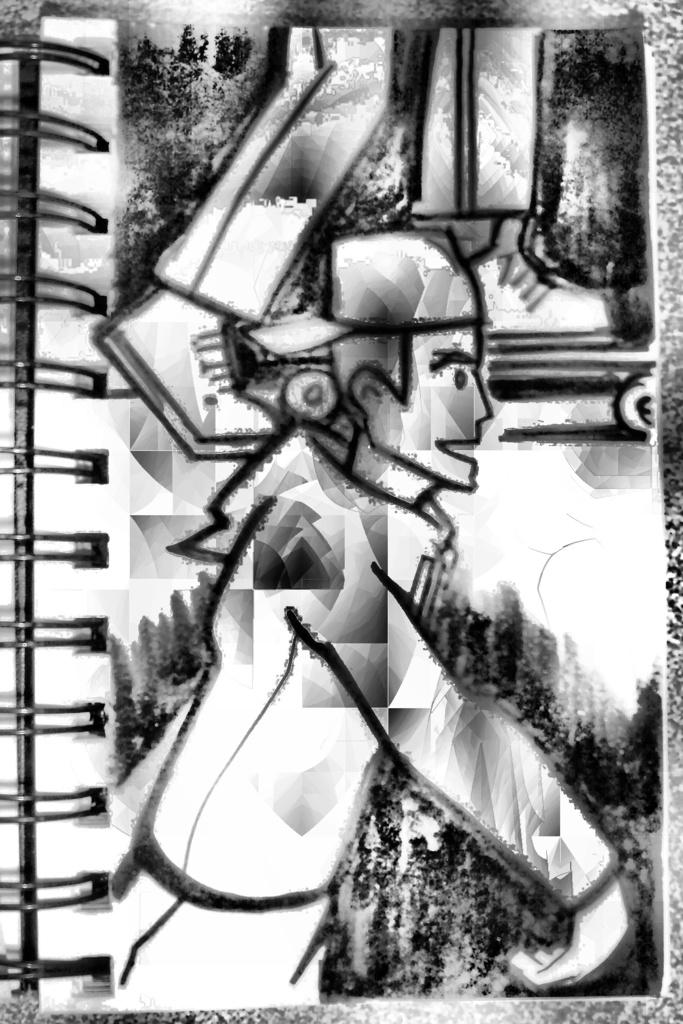What is depicted on the paper in the image? There is a sketch on the paper. What is the subject of the sketch? The sketch is of a person. What color is the sketch? The sketch is in black color. What type of binding is present on the paper? There is spiral binding on the left side of the paper. What type of war is depicted in the sketch? There is no war depicted in the sketch; it is a sketch of a person. Can you tell me how many crackers are present in the image? There are no crackers present in the image; it features a sketch of a person on a piece of paper with spiral binding. 